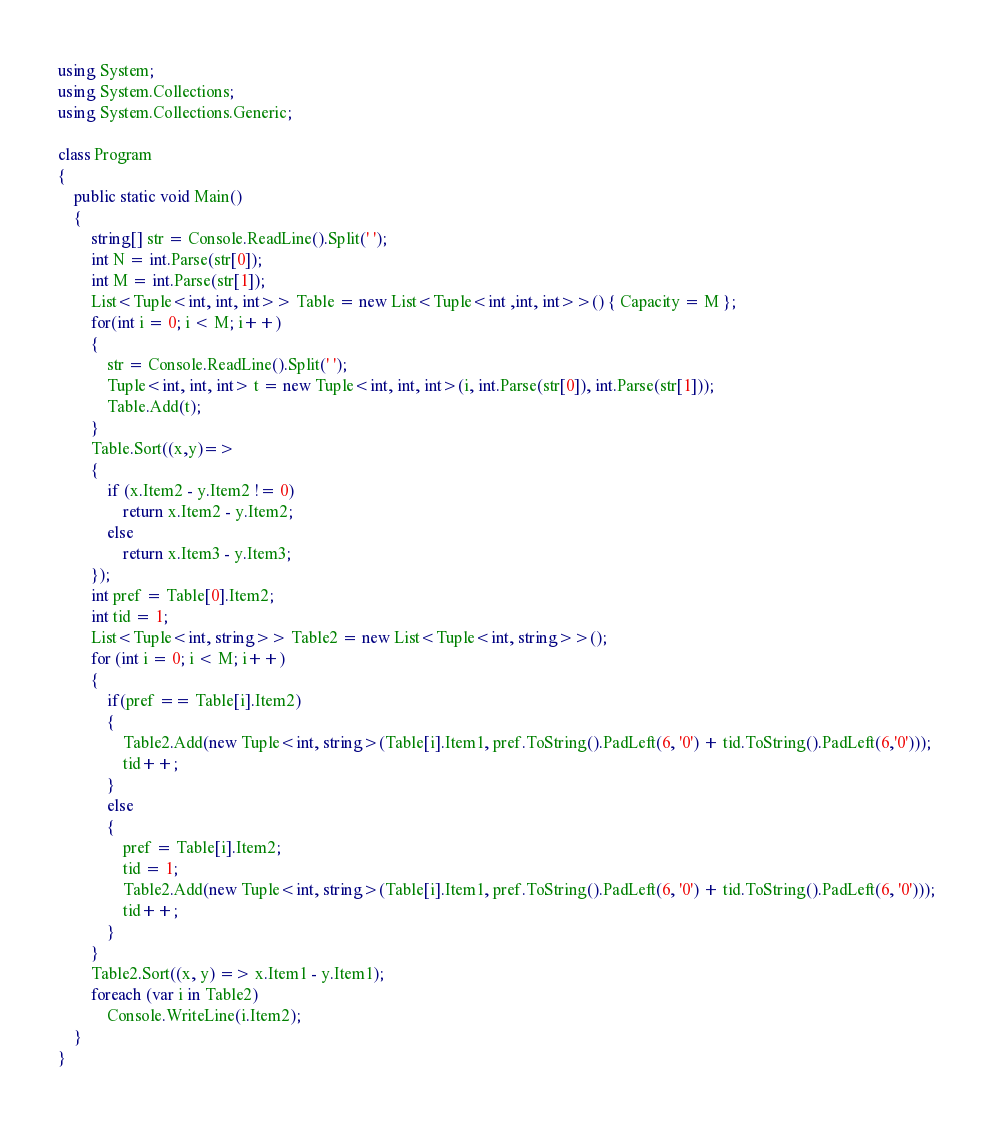Convert code to text. <code><loc_0><loc_0><loc_500><loc_500><_C#_>using System;
using System.Collections;
using System.Collections.Generic;

class Program
{
    public static void Main()
    {
        string[] str = Console.ReadLine().Split(' ');
        int N = int.Parse(str[0]);
        int M = int.Parse(str[1]);
        List<Tuple<int, int, int>> Table = new List<Tuple<int ,int, int>>() { Capacity = M };
        for(int i = 0; i < M; i++)
        {
            str = Console.ReadLine().Split(' ');
            Tuple<int, int, int> t = new Tuple<int, int, int>(i, int.Parse(str[0]), int.Parse(str[1]));
            Table.Add(t);
        }
        Table.Sort((x,y)=>
        {
            if (x.Item2 - y.Item2 != 0)
                return x.Item2 - y.Item2;
            else
                return x.Item3 - y.Item3;
        });
        int pref = Table[0].Item2;
        int tid = 1;
        List<Tuple<int, string>> Table2 = new List<Tuple<int, string>>();
        for (int i = 0; i < M; i++)
        {
            if(pref == Table[i].Item2)
            {
                Table2.Add(new Tuple<int, string>(Table[i].Item1, pref.ToString().PadLeft(6, '0') + tid.ToString().PadLeft(6,'0')));
                tid++;
            }
            else
            {
                pref = Table[i].Item2;
                tid = 1;
                Table2.Add(new Tuple<int, string>(Table[i].Item1, pref.ToString().PadLeft(6, '0') + tid.ToString().PadLeft(6, '0')));
                tid++;
            }
        }
        Table2.Sort((x, y) => x.Item1 - y.Item1);
        foreach (var i in Table2)
            Console.WriteLine(i.Item2);
    }
}</code> 